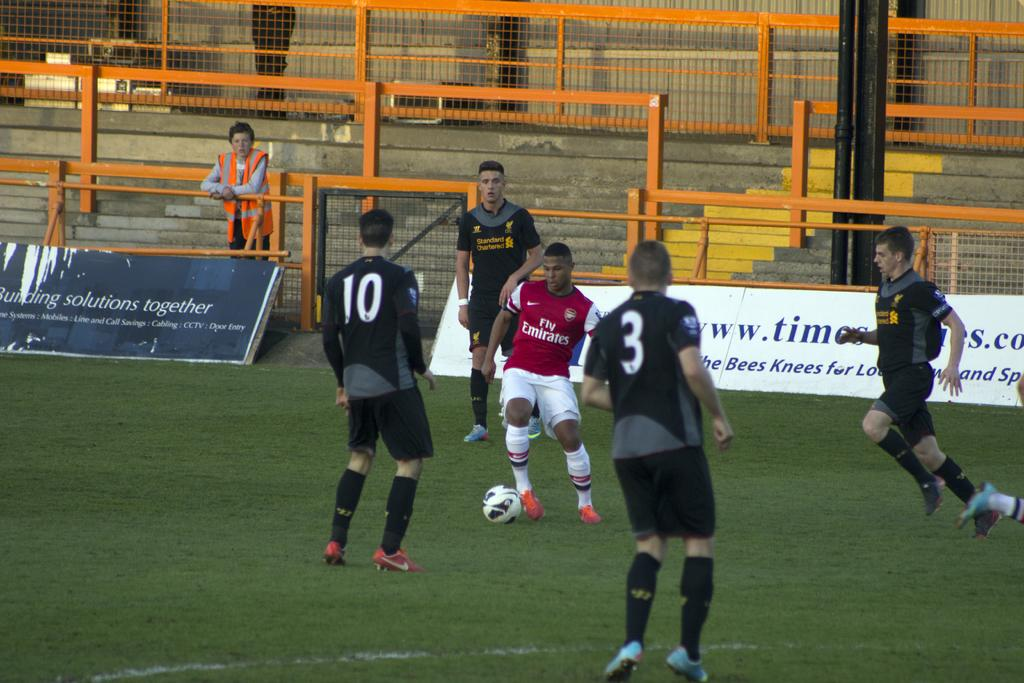<image>
Summarize the visual content of the image. Players 10 and 3 are keeping their eyes on the player who currently has the ball. 